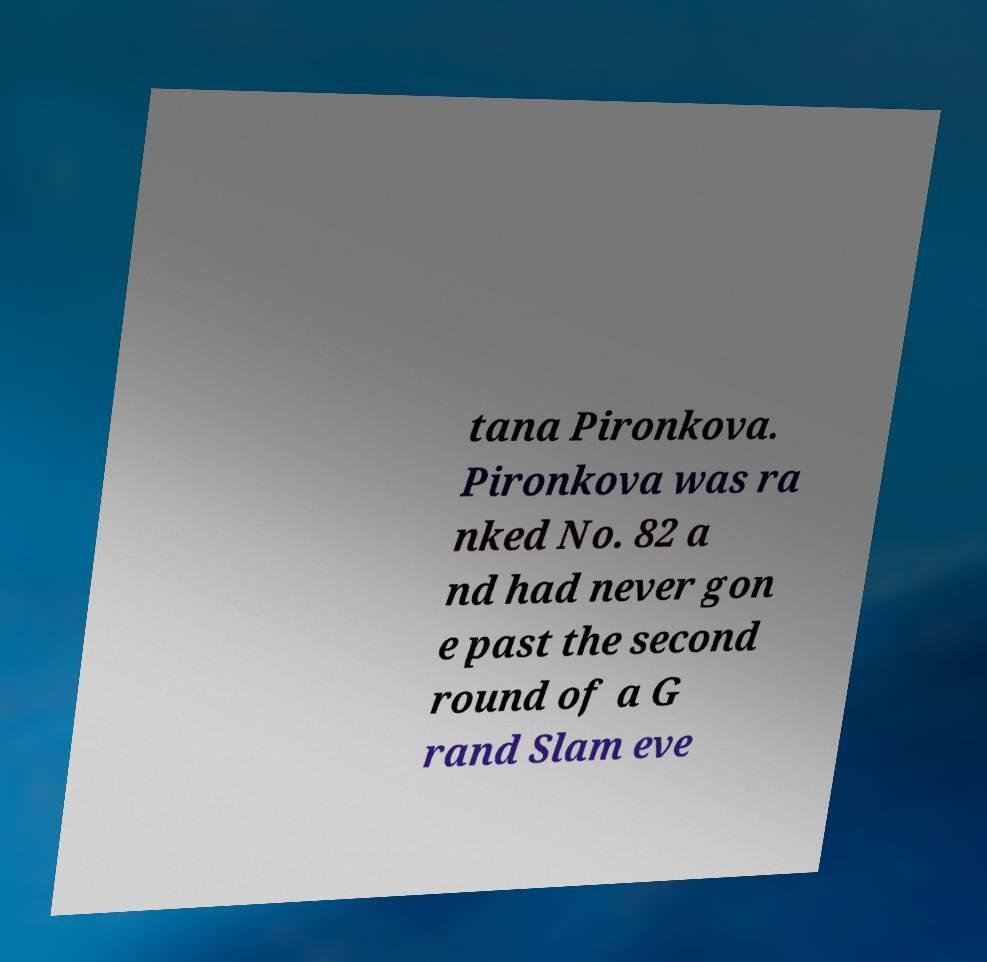I need the written content from this picture converted into text. Can you do that? tana Pironkova. Pironkova was ra nked No. 82 a nd had never gon e past the second round of a G rand Slam eve 